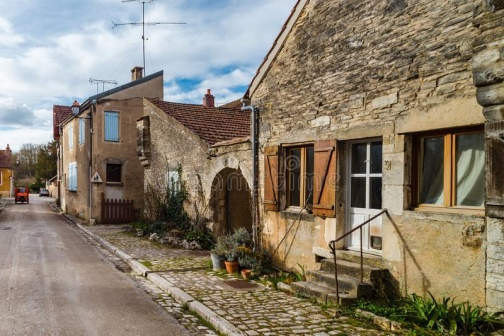What's happening in the scene? The image captures a peaceful moment in a picturesque village. The narrow, cobblestone street running through the center leads to charming stone houses on the right side. Each house is adorned with a warm orange roof, adding to the inviting feel of the scene.

On the far right, there's a house with a cozy garden featuring potted plants, all enclosed by a quaint wooden gate. The middle house has a distinctive white door and green shutters, while the house on the left is marked by a blue door and white shutters.

Farther back, power lines crisscross the sky, linking the houses, and a solitary street lamp stands by, suggesting the impending dusk. The atmosphere is tranquil, exuding a timeless charm that's characteristic of such idyllic villages. 